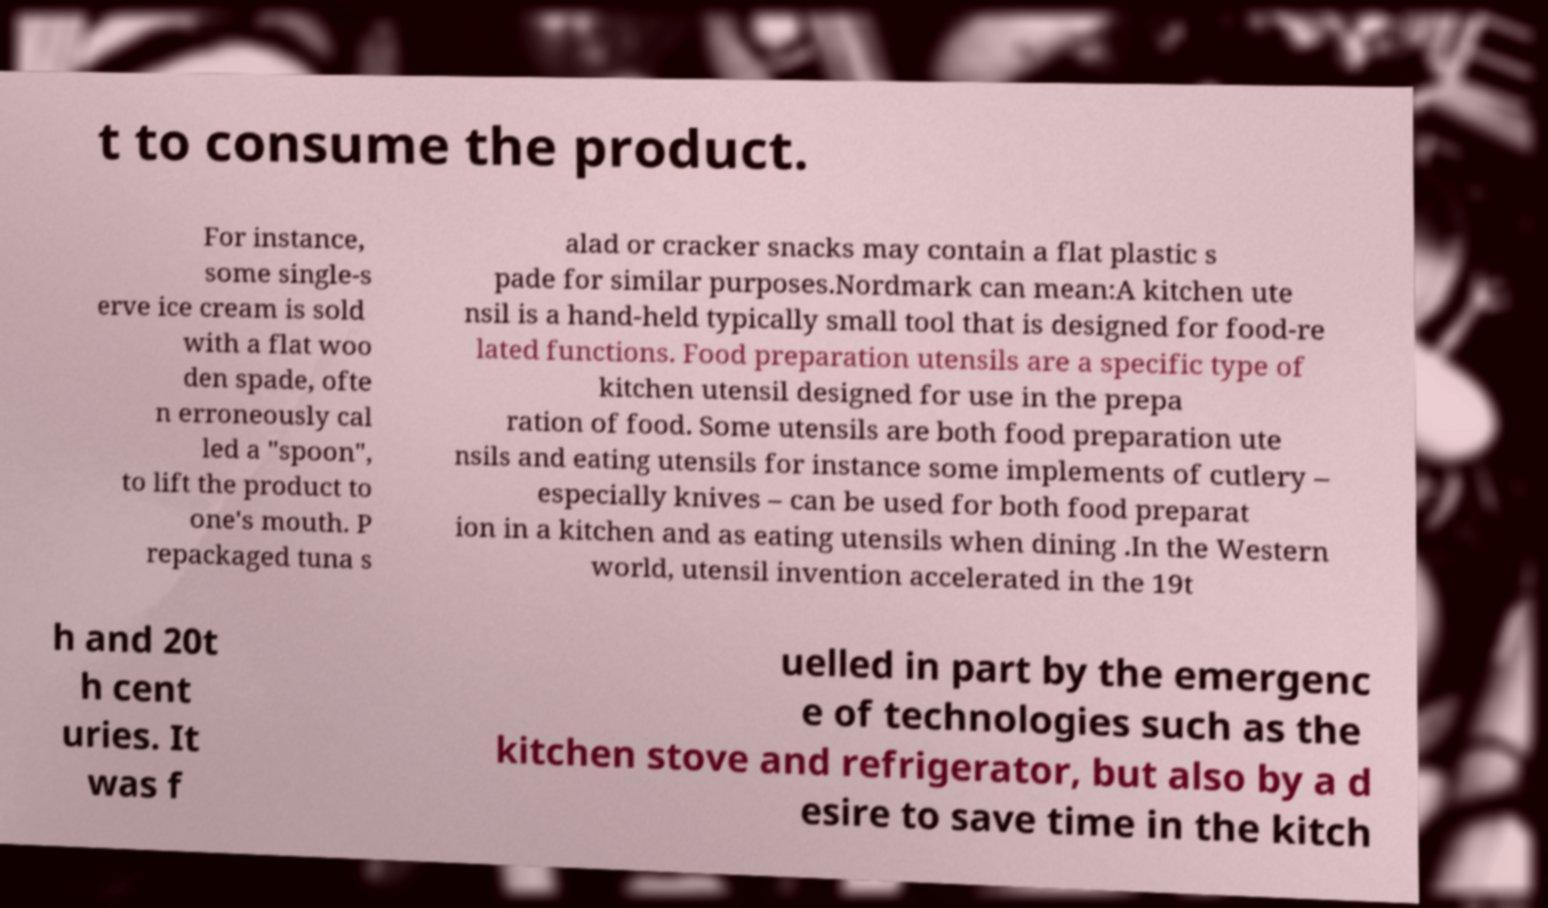What messages or text are displayed in this image? I need them in a readable, typed format. t to consume the product. For instance, some single-s erve ice cream is sold with a flat woo den spade, ofte n erroneously cal led a "spoon", to lift the product to one's mouth. P repackaged tuna s alad or cracker snacks may contain a flat plastic s pade for similar purposes.Nordmark can mean:A kitchen ute nsil is a hand-held typically small tool that is designed for food-re lated functions. Food preparation utensils are a specific type of kitchen utensil designed for use in the prepa ration of food. Some utensils are both food preparation ute nsils and eating utensils for instance some implements of cutlery – especially knives – can be used for both food preparat ion in a kitchen and as eating utensils when dining .In the Western world, utensil invention accelerated in the 19t h and 20t h cent uries. It was f uelled in part by the emergenc e of technologies such as the kitchen stove and refrigerator, but also by a d esire to save time in the kitch 